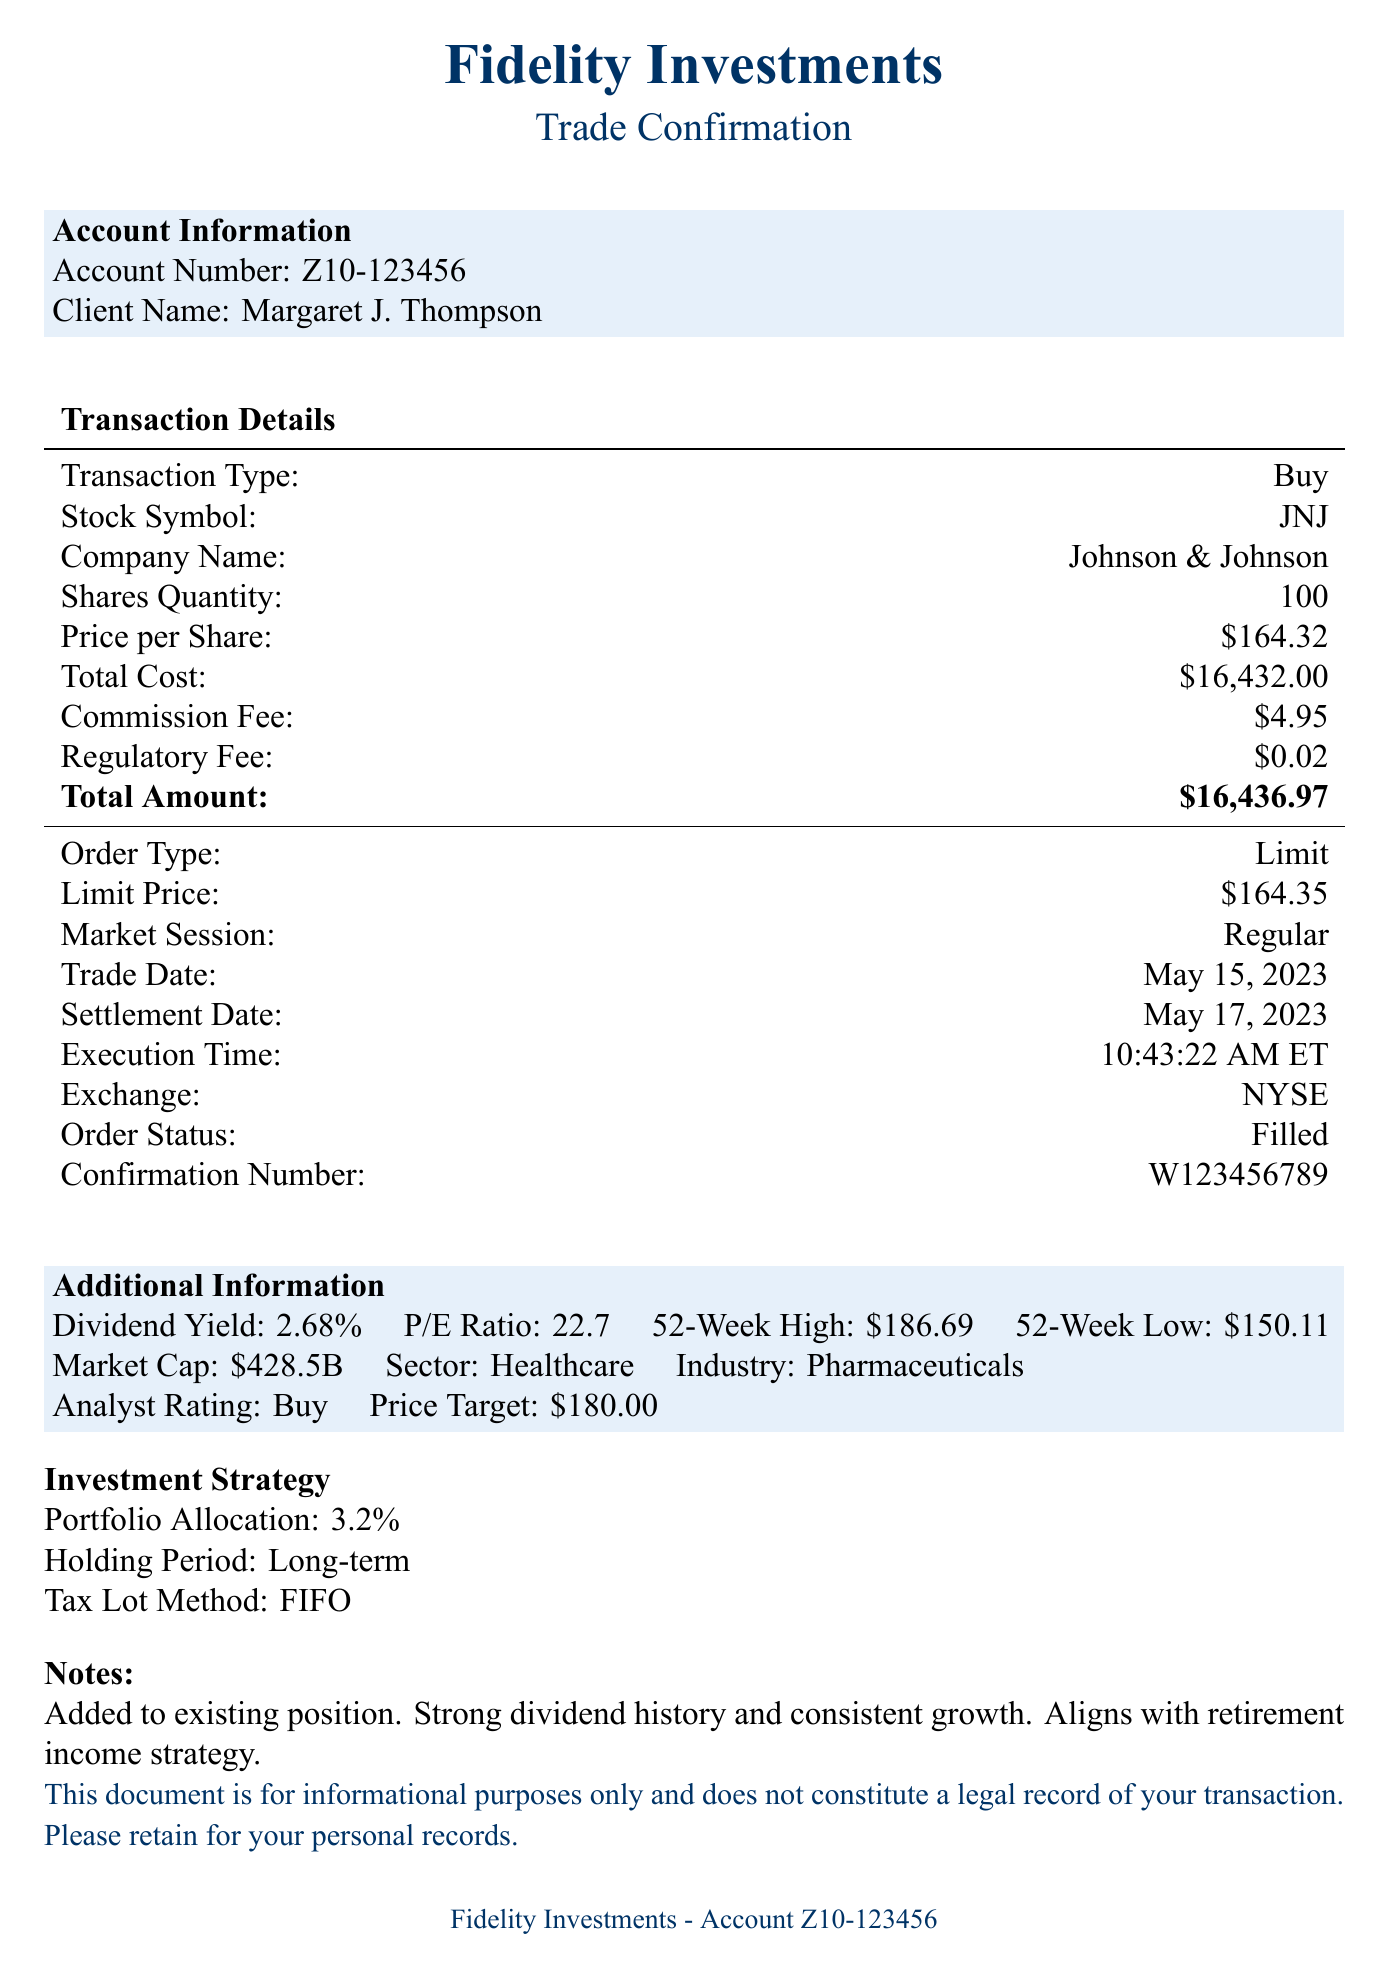What is the brokerage name? The brokerage name is prominently displayed at the top of the document, identifying the financial institution involved.
Answer: Fidelity Investments What is the total amount of the transaction? The total amount is calculated by adding the total cost, commission fee, and regulatory fee in the document.
Answer: $16,436.97 What is the execution time of the trade? The execution time is specifically noted in the transaction details section of the document.
Answer: 10:43:22 AM ET What is the price per share? The price per share is listed in the transaction details, indicating the cost of a single share of stock.
Answer: $164.32 What is the limit price for the order? The limit price for the order is noted and specifies the maximum price the buyer is willing to pay.
Answer: $164.35 What is the analyst rating for the stock? The analyst rating provides insight into the stock's expected performance based on expert review.
Answer: Buy What is the P/E ratio mentioned in the document? The P/E ratio reflects the stock's price relative to its earnings and is included in the additional information section.
Answer: 22.7 What is the settlement date for the transaction? The settlement date is when the transaction is finalized and recorded, which is shorter than the trade date.
Answer: May 17, 2023 What is the holding period indicated in the investment strategy? The holding period specifies the length of time the investor intends to keep the stock.
Answer: Long-term 